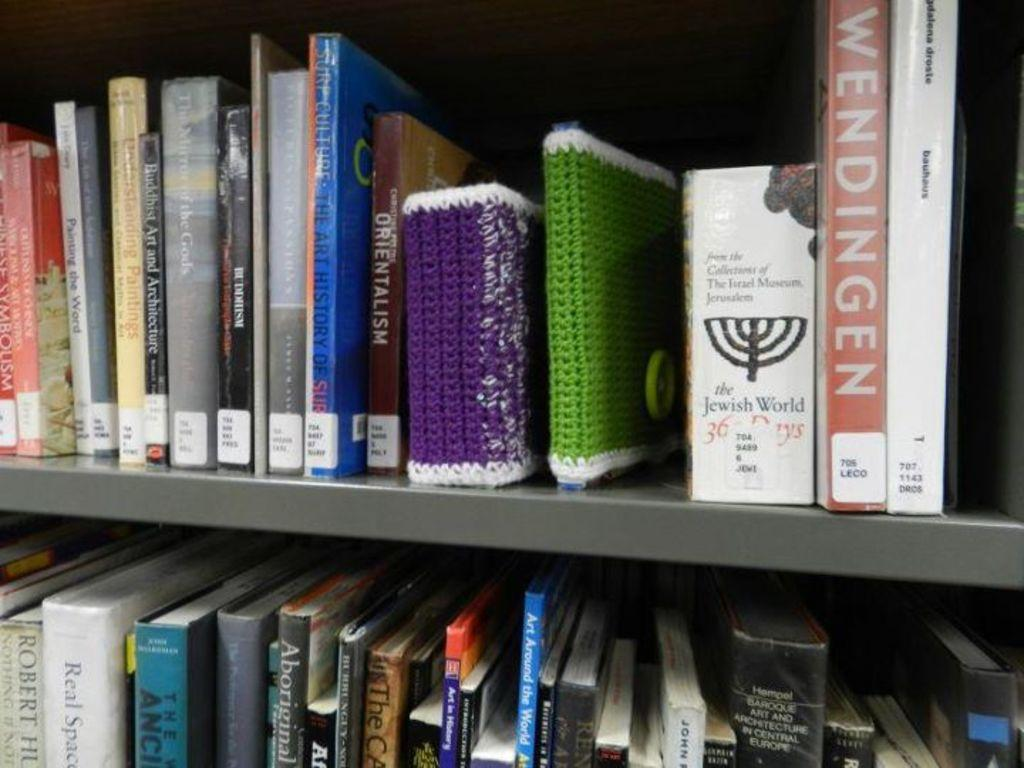<image>
Render a clear and concise summary of the photo. One of the many books that can be seen is titled Wendingen 